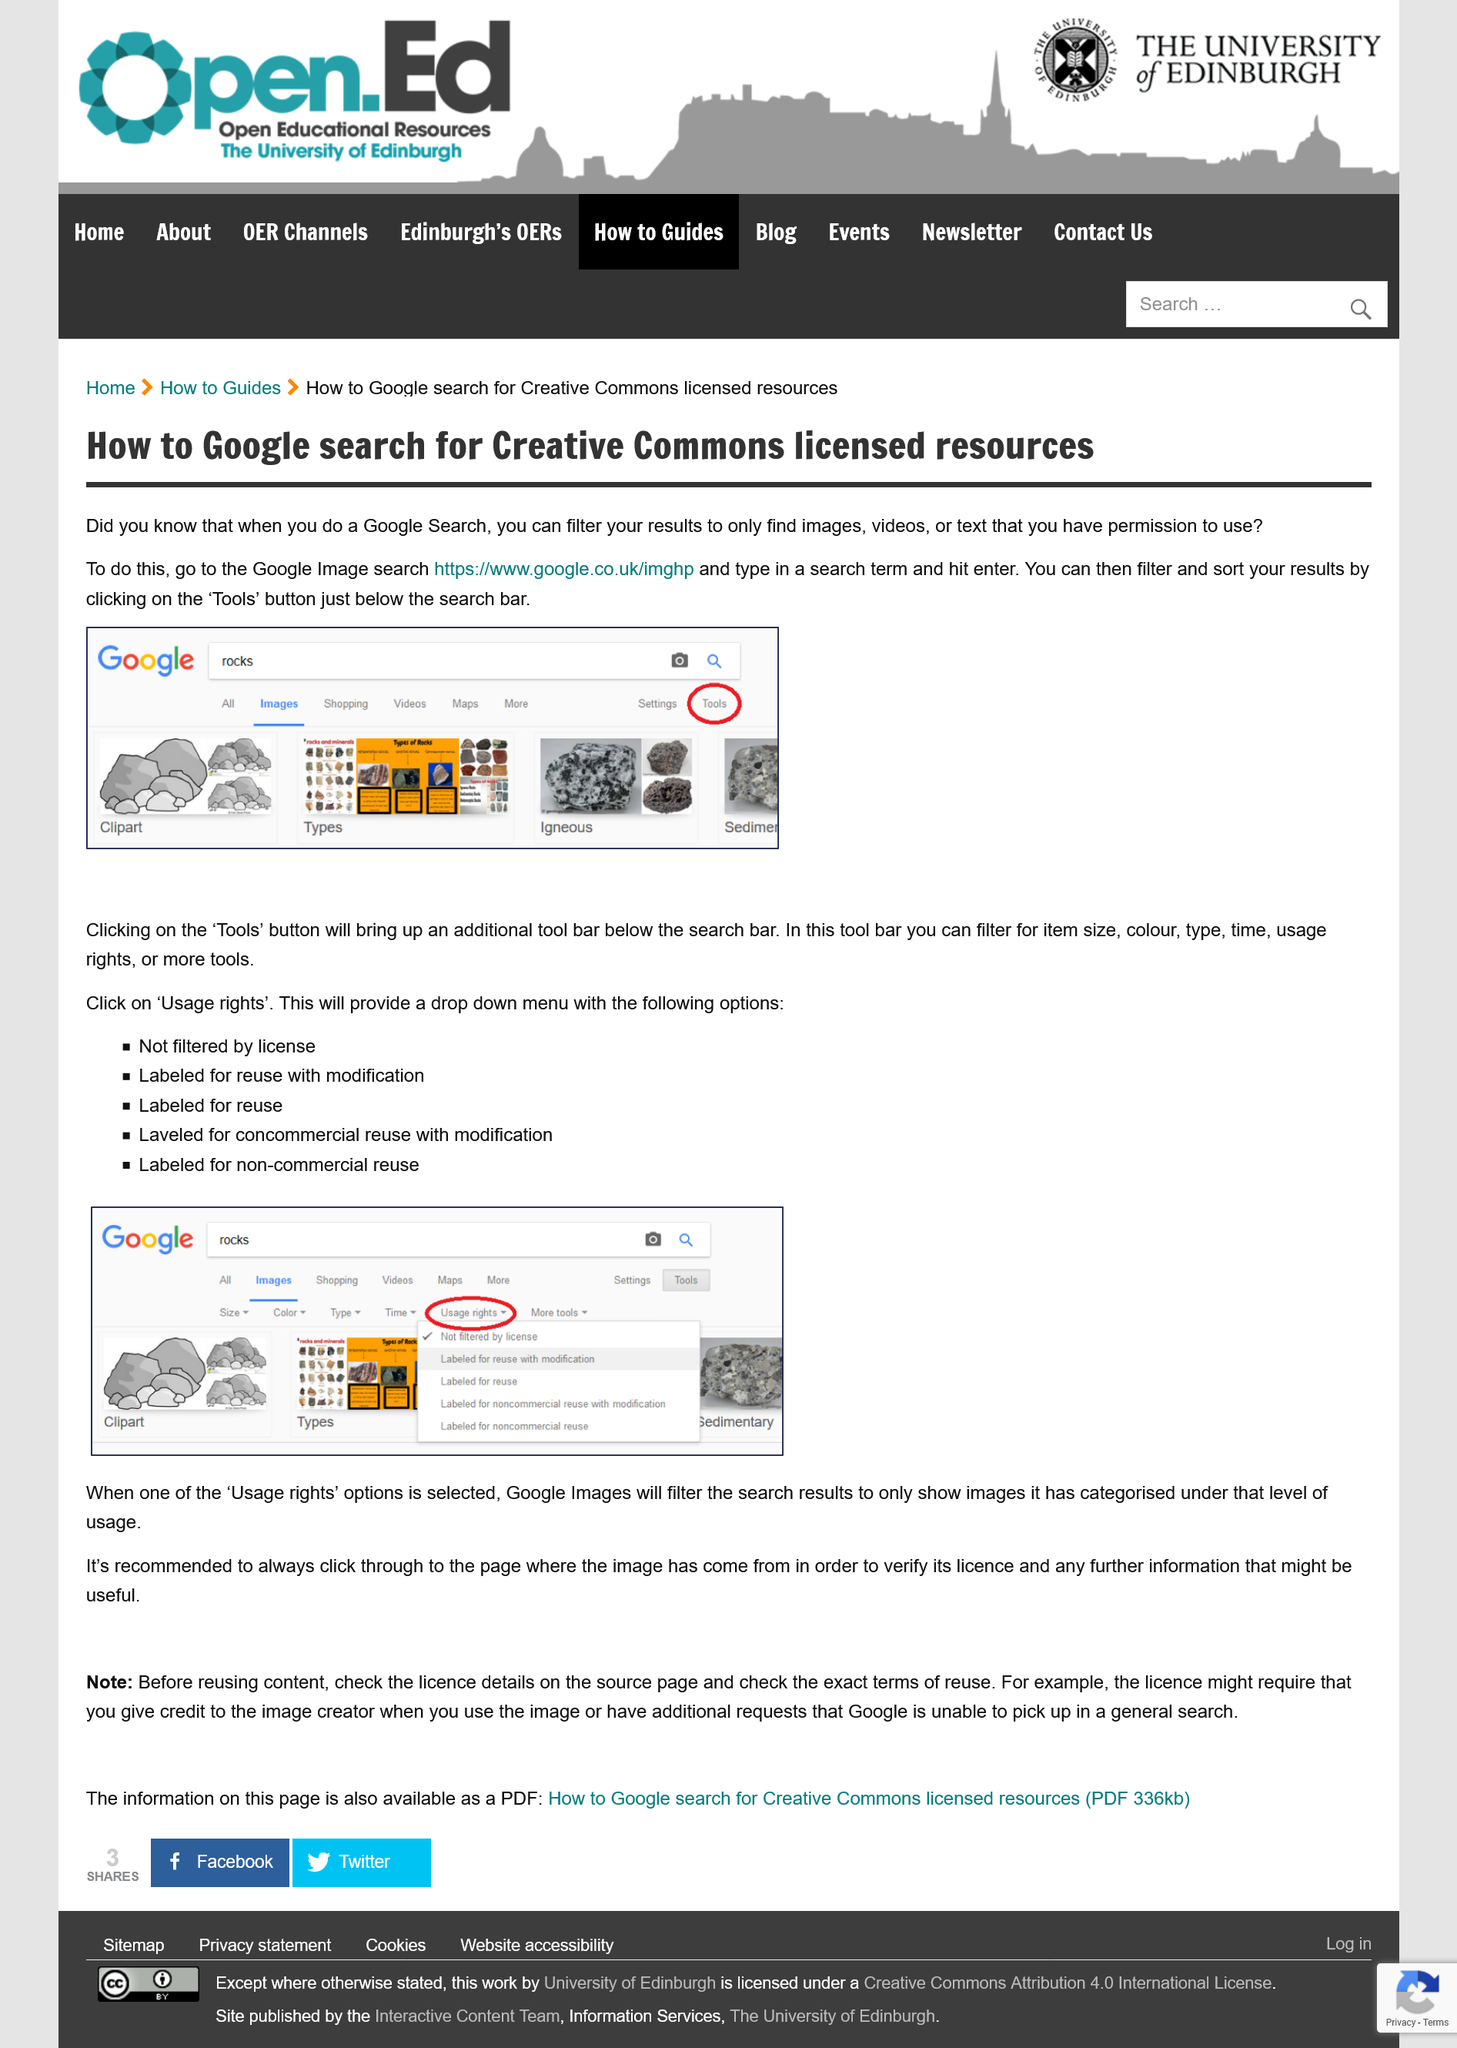List a handful of essential elements in this visual. To search for images that you have permission to use, you should first click on the "Tools" button, followed by "Usage Rights". Then, you can use the dropdown menu to filter the search results. The "Tools" button is intended for filtering and sorting search results. The image has been searched for rocks. The tools button is located below the search icon on the screen, and it is positioned in close proximity to the area where the tools bar is typically located. Before reusing content, it is important to check the exact terms of reuse and verify the image's license to ensure proper attribution and compliance with copyright law. 